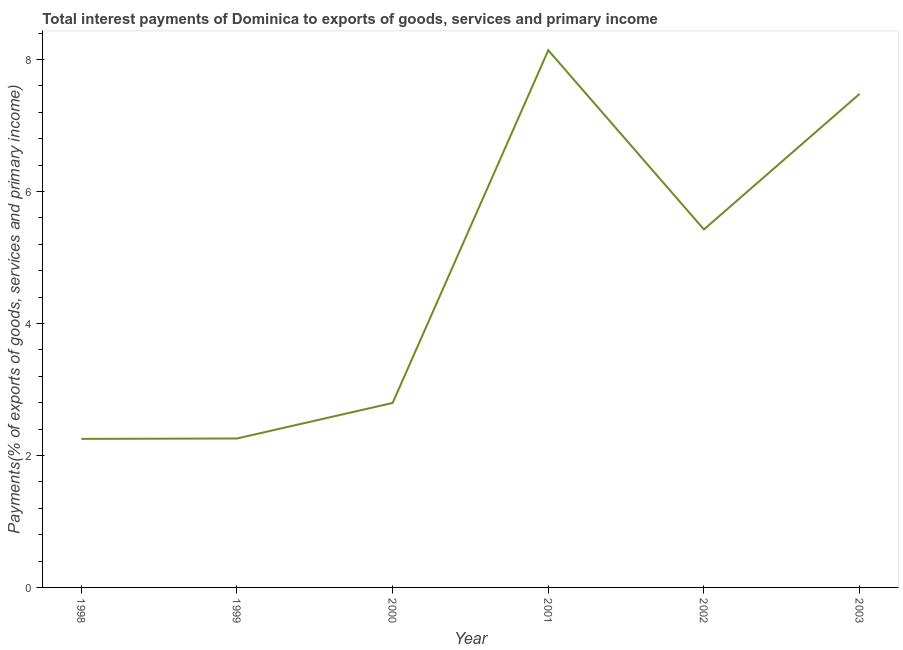What is the total interest payments on external debt in 2000?
Offer a terse response. 2.8. Across all years, what is the maximum total interest payments on external debt?
Provide a short and direct response. 8.14. Across all years, what is the minimum total interest payments on external debt?
Your answer should be compact. 2.25. In which year was the total interest payments on external debt maximum?
Provide a succinct answer. 2001. In which year was the total interest payments on external debt minimum?
Offer a terse response. 1998. What is the sum of the total interest payments on external debt?
Your answer should be compact. 28.35. What is the difference between the total interest payments on external debt in 2000 and 2003?
Make the answer very short. -4.68. What is the average total interest payments on external debt per year?
Give a very brief answer. 4.73. What is the median total interest payments on external debt?
Give a very brief answer. 4.11. What is the ratio of the total interest payments on external debt in 1999 to that in 2002?
Offer a terse response. 0.42. Is the total interest payments on external debt in 1998 less than that in 2001?
Your response must be concise. Yes. Is the difference between the total interest payments on external debt in 2001 and 2003 greater than the difference between any two years?
Offer a very short reply. No. What is the difference between the highest and the second highest total interest payments on external debt?
Offer a very short reply. 0.66. What is the difference between the highest and the lowest total interest payments on external debt?
Keep it short and to the point. 5.89. What is the difference between two consecutive major ticks on the Y-axis?
Give a very brief answer. 2. Are the values on the major ticks of Y-axis written in scientific E-notation?
Give a very brief answer. No. What is the title of the graph?
Make the answer very short. Total interest payments of Dominica to exports of goods, services and primary income. What is the label or title of the X-axis?
Your answer should be very brief. Year. What is the label or title of the Y-axis?
Ensure brevity in your answer.  Payments(% of exports of goods, services and primary income). What is the Payments(% of exports of goods, services and primary income) in 1998?
Provide a short and direct response. 2.25. What is the Payments(% of exports of goods, services and primary income) of 1999?
Provide a short and direct response. 2.26. What is the Payments(% of exports of goods, services and primary income) in 2000?
Ensure brevity in your answer.  2.8. What is the Payments(% of exports of goods, services and primary income) of 2001?
Your response must be concise. 8.14. What is the Payments(% of exports of goods, services and primary income) in 2002?
Your response must be concise. 5.43. What is the Payments(% of exports of goods, services and primary income) of 2003?
Offer a terse response. 7.48. What is the difference between the Payments(% of exports of goods, services and primary income) in 1998 and 1999?
Provide a short and direct response. -0.01. What is the difference between the Payments(% of exports of goods, services and primary income) in 1998 and 2000?
Give a very brief answer. -0.54. What is the difference between the Payments(% of exports of goods, services and primary income) in 1998 and 2001?
Offer a very short reply. -5.89. What is the difference between the Payments(% of exports of goods, services and primary income) in 1998 and 2002?
Keep it short and to the point. -3.17. What is the difference between the Payments(% of exports of goods, services and primary income) in 1998 and 2003?
Your answer should be compact. -5.23. What is the difference between the Payments(% of exports of goods, services and primary income) in 1999 and 2000?
Offer a terse response. -0.54. What is the difference between the Payments(% of exports of goods, services and primary income) in 1999 and 2001?
Offer a very short reply. -5.88. What is the difference between the Payments(% of exports of goods, services and primary income) in 1999 and 2002?
Your answer should be very brief. -3.17. What is the difference between the Payments(% of exports of goods, services and primary income) in 1999 and 2003?
Give a very brief answer. -5.22. What is the difference between the Payments(% of exports of goods, services and primary income) in 2000 and 2001?
Offer a terse response. -5.35. What is the difference between the Payments(% of exports of goods, services and primary income) in 2000 and 2002?
Offer a very short reply. -2.63. What is the difference between the Payments(% of exports of goods, services and primary income) in 2000 and 2003?
Provide a succinct answer. -4.68. What is the difference between the Payments(% of exports of goods, services and primary income) in 2001 and 2002?
Make the answer very short. 2.72. What is the difference between the Payments(% of exports of goods, services and primary income) in 2001 and 2003?
Offer a very short reply. 0.66. What is the difference between the Payments(% of exports of goods, services and primary income) in 2002 and 2003?
Keep it short and to the point. -2.05. What is the ratio of the Payments(% of exports of goods, services and primary income) in 1998 to that in 1999?
Your answer should be compact. 1. What is the ratio of the Payments(% of exports of goods, services and primary income) in 1998 to that in 2000?
Give a very brief answer. 0.81. What is the ratio of the Payments(% of exports of goods, services and primary income) in 1998 to that in 2001?
Offer a very short reply. 0.28. What is the ratio of the Payments(% of exports of goods, services and primary income) in 1998 to that in 2002?
Provide a succinct answer. 0.41. What is the ratio of the Payments(% of exports of goods, services and primary income) in 1998 to that in 2003?
Provide a short and direct response. 0.3. What is the ratio of the Payments(% of exports of goods, services and primary income) in 1999 to that in 2000?
Your response must be concise. 0.81. What is the ratio of the Payments(% of exports of goods, services and primary income) in 1999 to that in 2001?
Your answer should be very brief. 0.28. What is the ratio of the Payments(% of exports of goods, services and primary income) in 1999 to that in 2002?
Give a very brief answer. 0.42. What is the ratio of the Payments(% of exports of goods, services and primary income) in 1999 to that in 2003?
Offer a very short reply. 0.3. What is the ratio of the Payments(% of exports of goods, services and primary income) in 2000 to that in 2001?
Offer a terse response. 0.34. What is the ratio of the Payments(% of exports of goods, services and primary income) in 2000 to that in 2002?
Give a very brief answer. 0.52. What is the ratio of the Payments(% of exports of goods, services and primary income) in 2000 to that in 2003?
Give a very brief answer. 0.37. What is the ratio of the Payments(% of exports of goods, services and primary income) in 2001 to that in 2002?
Your answer should be very brief. 1.5. What is the ratio of the Payments(% of exports of goods, services and primary income) in 2001 to that in 2003?
Provide a short and direct response. 1.09. What is the ratio of the Payments(% of exports of goods, services and primary income) in 2002 to that in 2003?
Offer a very short reply. 0.72. 